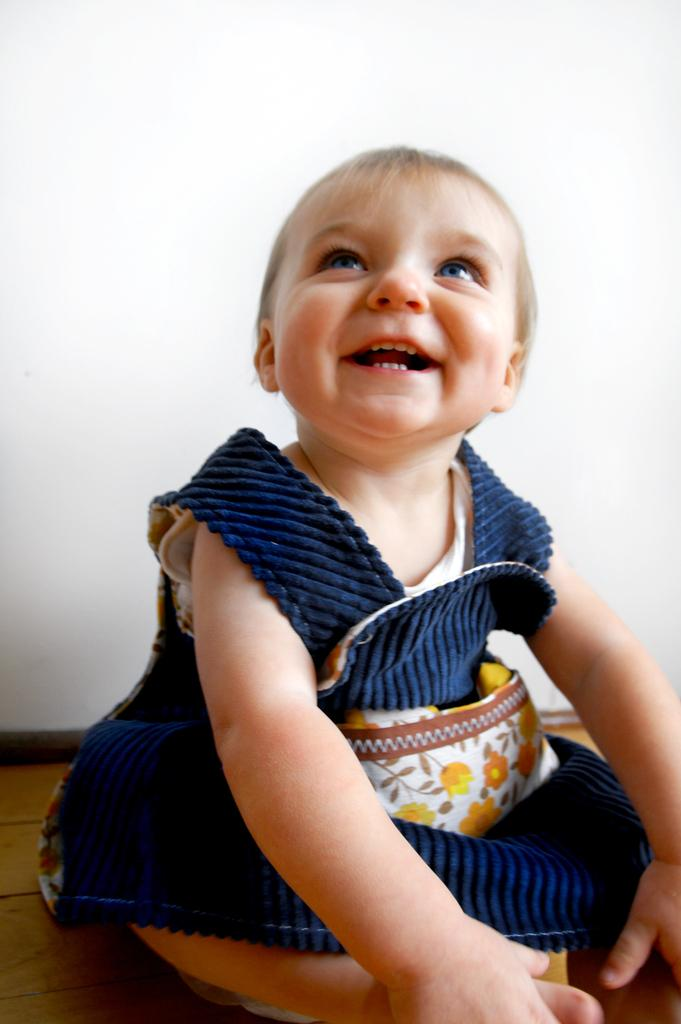What is the main subject of the picture? The main subject of the picture is a baby. What is the baby wearing? The baby is wearing a blue dress. Where is the baby sitting? The baby is sitting on a wooden surface. What is the baby's expression? The baby is smiling. What can be seen in the background of the picture? There is a white wall in the background of the picture. What type of glove is the baby wearing in the picture? There is no glove present in the picture; the baby is wearing a blue dress. What kind of operation is being performed on the baby in the picture? There is no operation being performed on the baby in the picture; the baby is simply sitting and smiling. 